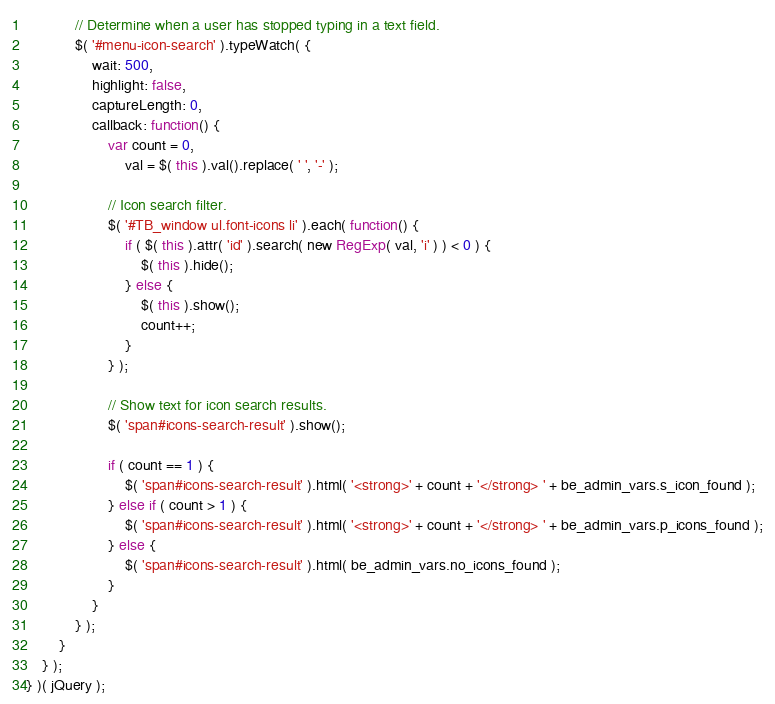<code> <loc_0><loc_0><loc_500><loc_500><_JavaScript_>
			// Determine when a user has stopped typing in a text field.
			$( '#menu-icon-search' ).typeWatch( {
				wait: 500,
				highlight: false,
				captureLength: 0,
				callback: function() {
					var count = 0,
						val = $( this ).val().replace( ' ', '-' );

					// Icon search filter.
					$( '#TB_window ul.font-icons li' ).each( function() {
						if ( $( this ).attr( 'id' ).search( new RegExp( val, 'i' ) ) < 0 ) {
							$( this ).hide();
						} else {
							$( this ).show();
							count++;
						}
					} );

					// Show text for icon search results.
					$( 'span#icons-search-result' ).show();

					if ( count == 1 ) {
						$( 'span#icons-search-result' ).html( '<strong>' + count + '</strong> ' + be_admin_vars.s_icon_found );
					} else if ( count > 1 ) {
						$( 'span#icons-search-result' ).html( '<strong>' + count + '</strong> ' + be_admin_vars.p_icons_found );
					} else {
						$( 'span#icons-search-result' ).html( be_admin_vars.no_icons_found );
					}
				}
			} );
		}
	} );
} )( jQuery );</code> 